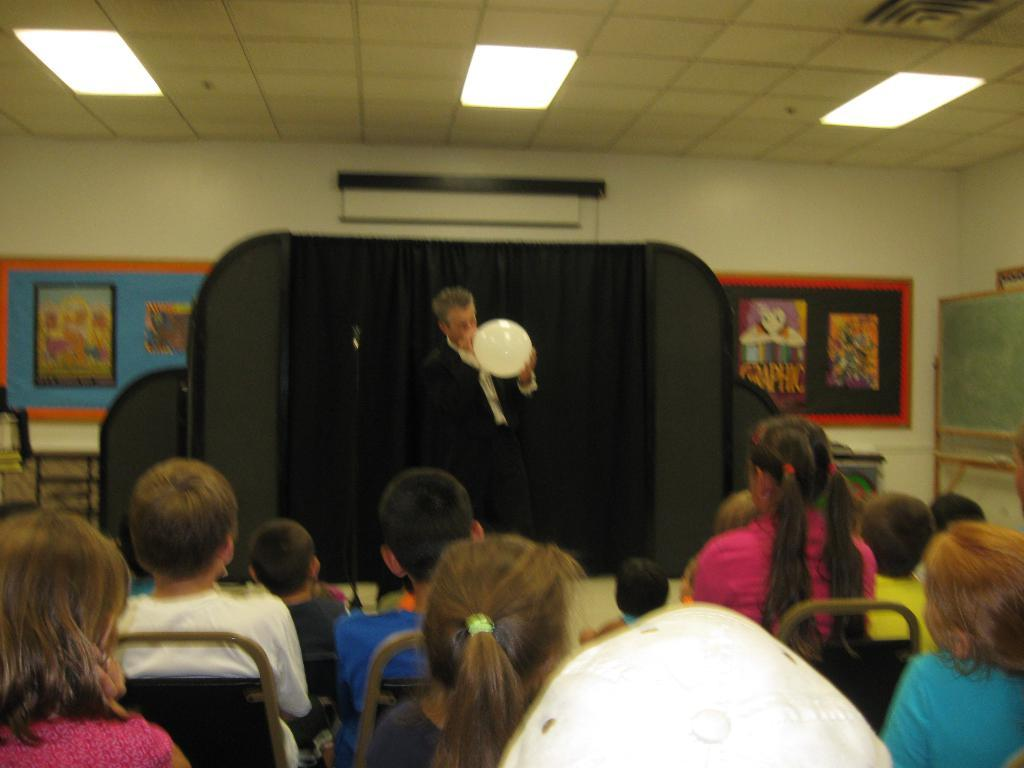What are the people in the foreground of the image doing? The people in the foreground of the image are sitting. What is the person holding in the image? The person is holding a balloon. What can be seen in the background of the image? There are posters and other objects in the background, as well as lamps. What type of teeth can be seen in the image? There are no teeth visible in the image. How many men are present in the image? The provided facts do not specify the gender of the people in the image, so it cannot be determined if there are any men present. 